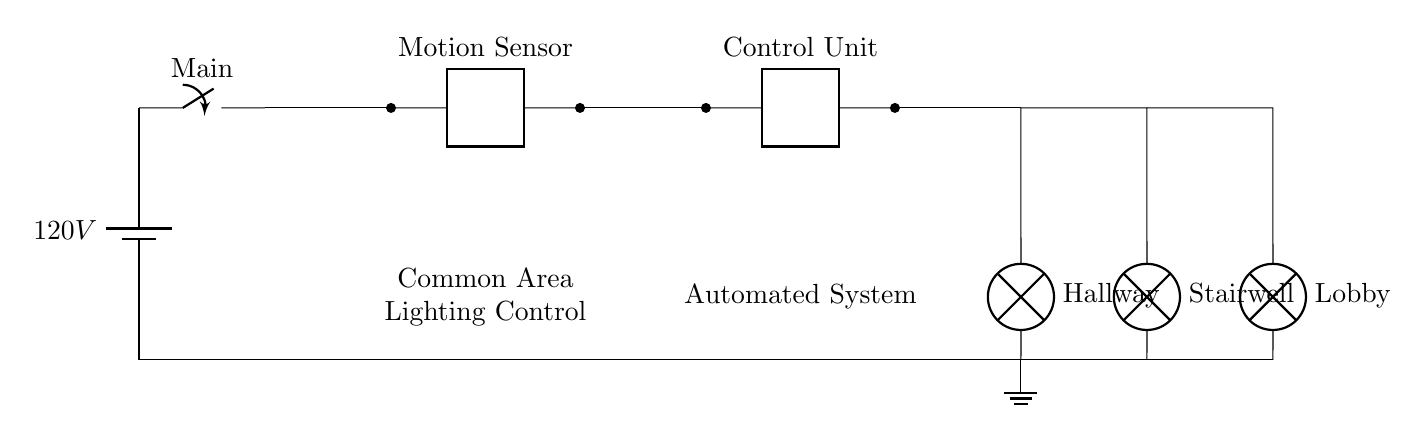What is the main voltage in this circuit? The main voltage is 120 volts, which is specified next to the battery symbol in the circuit diagram.
Answer: 120 volts What components control the lighting in the common areas? The lighting is controlled by both the motion sensor and the control unit, which are connected in series in the circuit. The motion sensor detects movement and communicates with the control unit to turn the lights on or off.
Answer: Motion sensor and control unit How many lamps are included in this circuit? There are three lamps indicated in the circuit diagram: the Hallway lamp, Stairwell lamp, and Lobby lamp.
Answer: Three lamps What happens when the motion sensor detects movement? When the motion sensor detects movement, it sends a signal to the control unit, which activates the connected lamps in the common areas to illuminate the space.
Answer: Lamps turn on Which area does the Hallway lamp illuminate? The Hallway lamp is located at the position labeled "Hallway" in the circuit, indicating it specifically illuminates the hallway area.
Answer: Hallway How are the components connected in the circuit? The components (battery, motion sensor, control unit, and lamps) are connected in series, starting from the battery to the main switch, then through the motion sensor, control unit, and finally to the lamps.
Answer: Series connection 